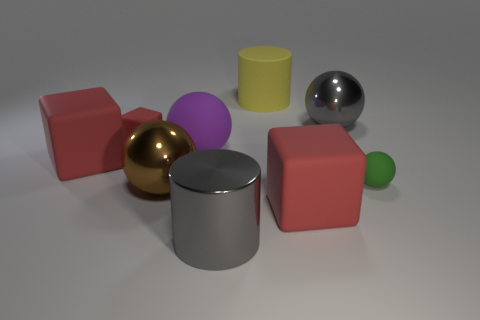Subtract all cylinders. How many objects are left? 7 Add 5 cyan metallic blocks. How many cyan metallic blocks exist? 5 Subtract 0 green cylinders. How many objects are left? 9 Subtract all tiny yellow objects. Subtract all big red rubber cubes. How many objects are left? 7 Add 9 small red cubes. How many small red cubes are left? 10 